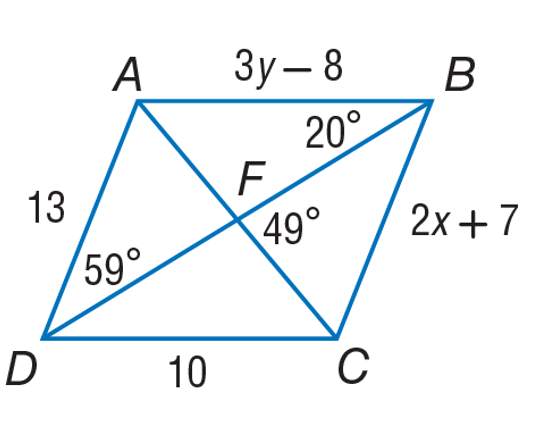What is the value of x in parallelogram ABCD? In parallelogram ABCD, side CD is labeled as 2x + 7 and is equal to side AB which measures 10 units. By setting 2x + 7 equal to 10, we can solve for x: 2x = 10 - 7, which means 2x = 3. Dividing both sides by 2, we find that x equals 1.5. So, the value of x is 1.5. 